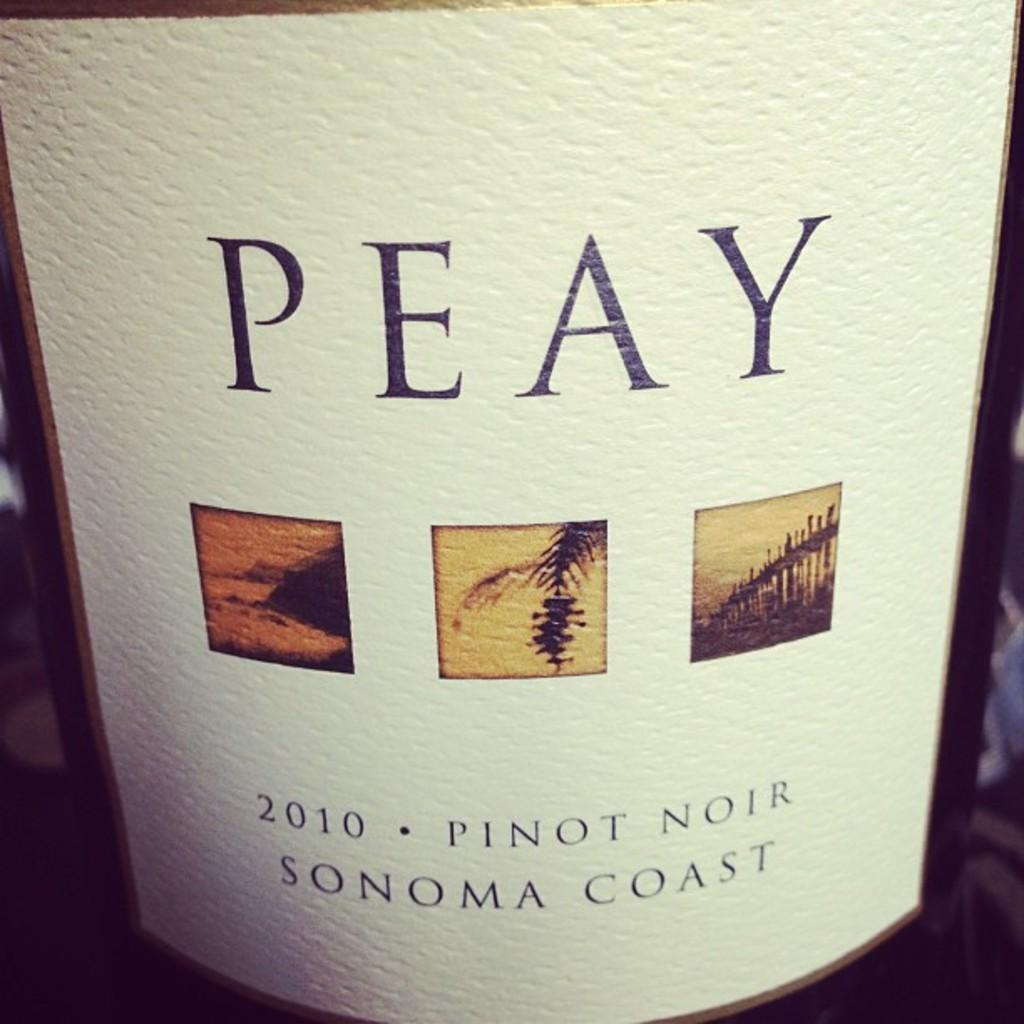<image>
Create a compact narrative representing the image presented. A bottle of wine that was made in 2010 